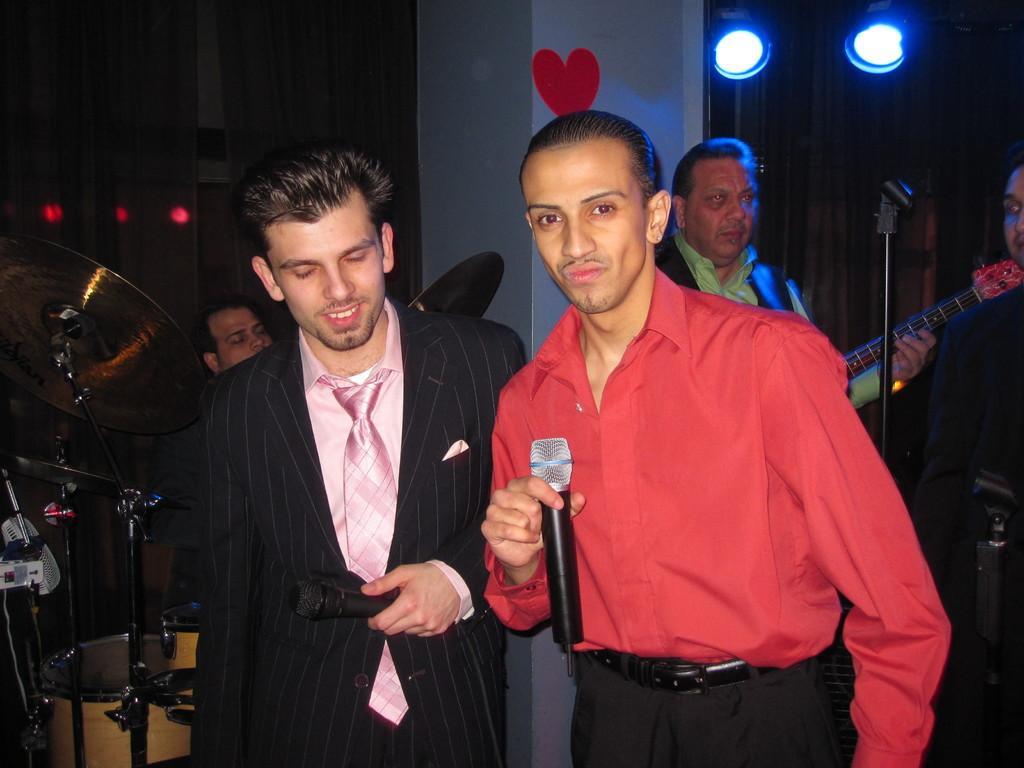How would you summarize this image in a sentence or two? This image consists of many people. In the front, there are two men standing. To the right, the man wearing red shirt is holding a mic. To the left the man standing is wearing a black suit and pink shirt. In the background, there is a pillar and lights on the wall. 